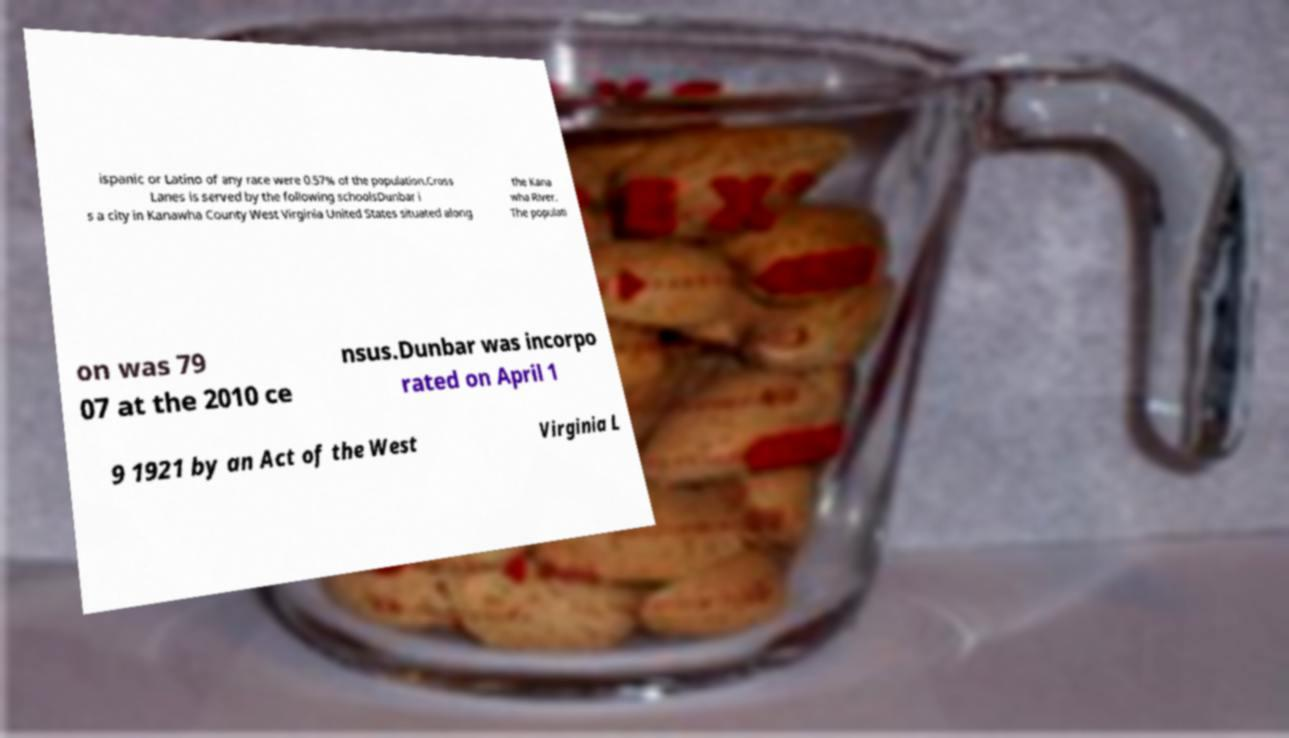Please identify and transcribe the text found in this image. ispanic or Latino of any race were 0.57% of the population.Cross Lanes is served by the following schoolsDunbar i s a city in Kanawha County West Virginia United States situated along the Kana wha River. The populati on was 79 07 at the 2010 ce nsus.Dunbar was incorpo rated on April 1 9 1921 by an Act of the West Virginia L 